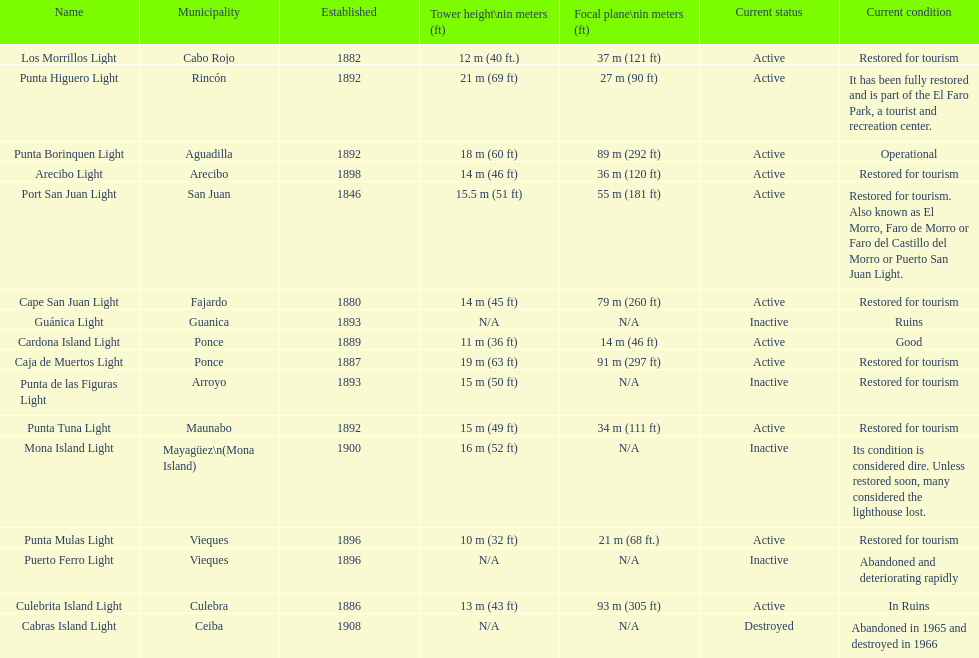What is the count of towers with a minimum height of 18 meters? 3. 